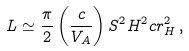Convert formula to latex. <formula><loc_0><loc_0><loc_500><loc_500>L \simeq \frac { \pi } { 2 } \left ( \frac { c } { V _ { A } } \right ) S ^ { 2 } H ^ { 2 } c r _ { H } ^ { 2 } \, ,</formula> 